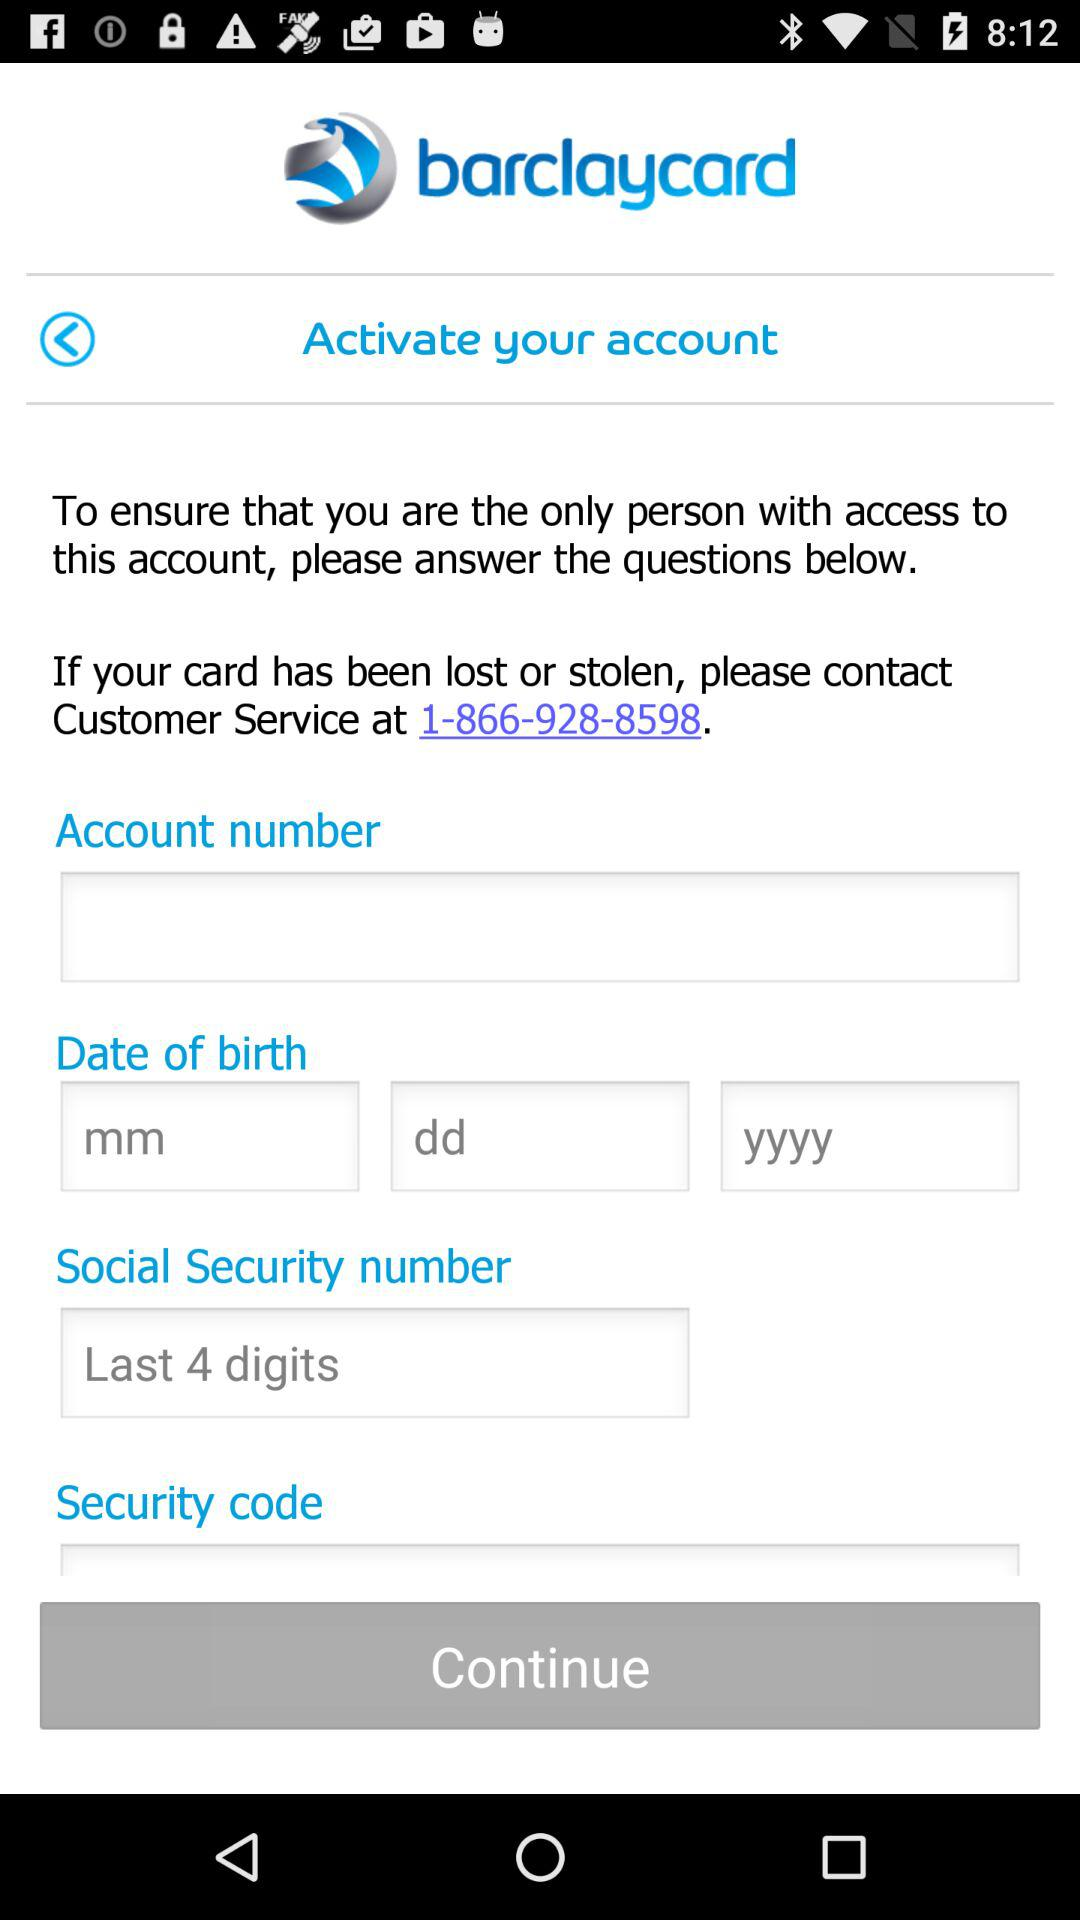What is the customer service number given for "Barclaycard"? The customer service number given for "Barclaycard" is 1-866-928-8598. 